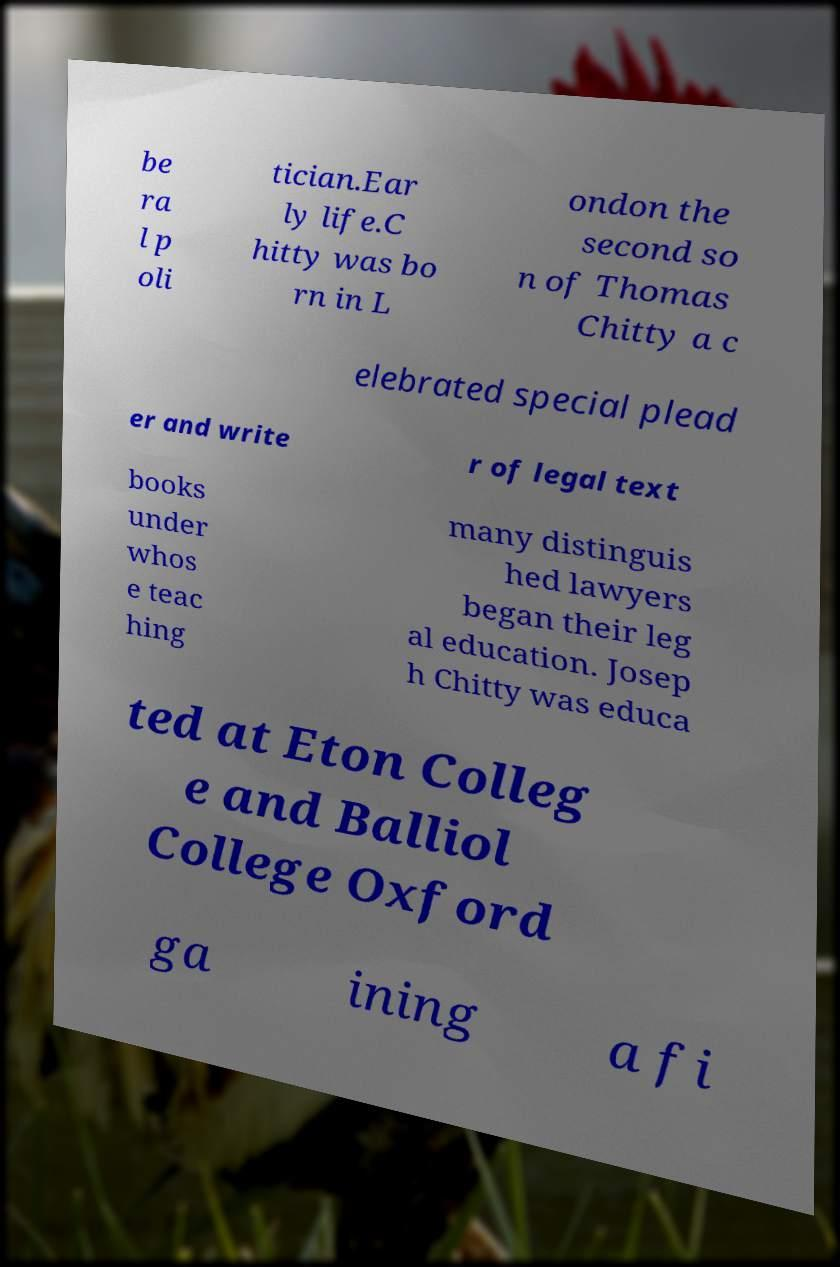Could you extract and type out the text from this image? be ra l p oli tician.Ear ly life.C hitty was bo rn in L ondon the second so n of Thomas Chitty a c elebrated special plead er and write r of legal text books under whos e teac hing many distinguis hed lawyers began their leg al education. Josep h Chitty was educa ted at Eton Colleg e and Balliol College Oxford ga ining a fi 